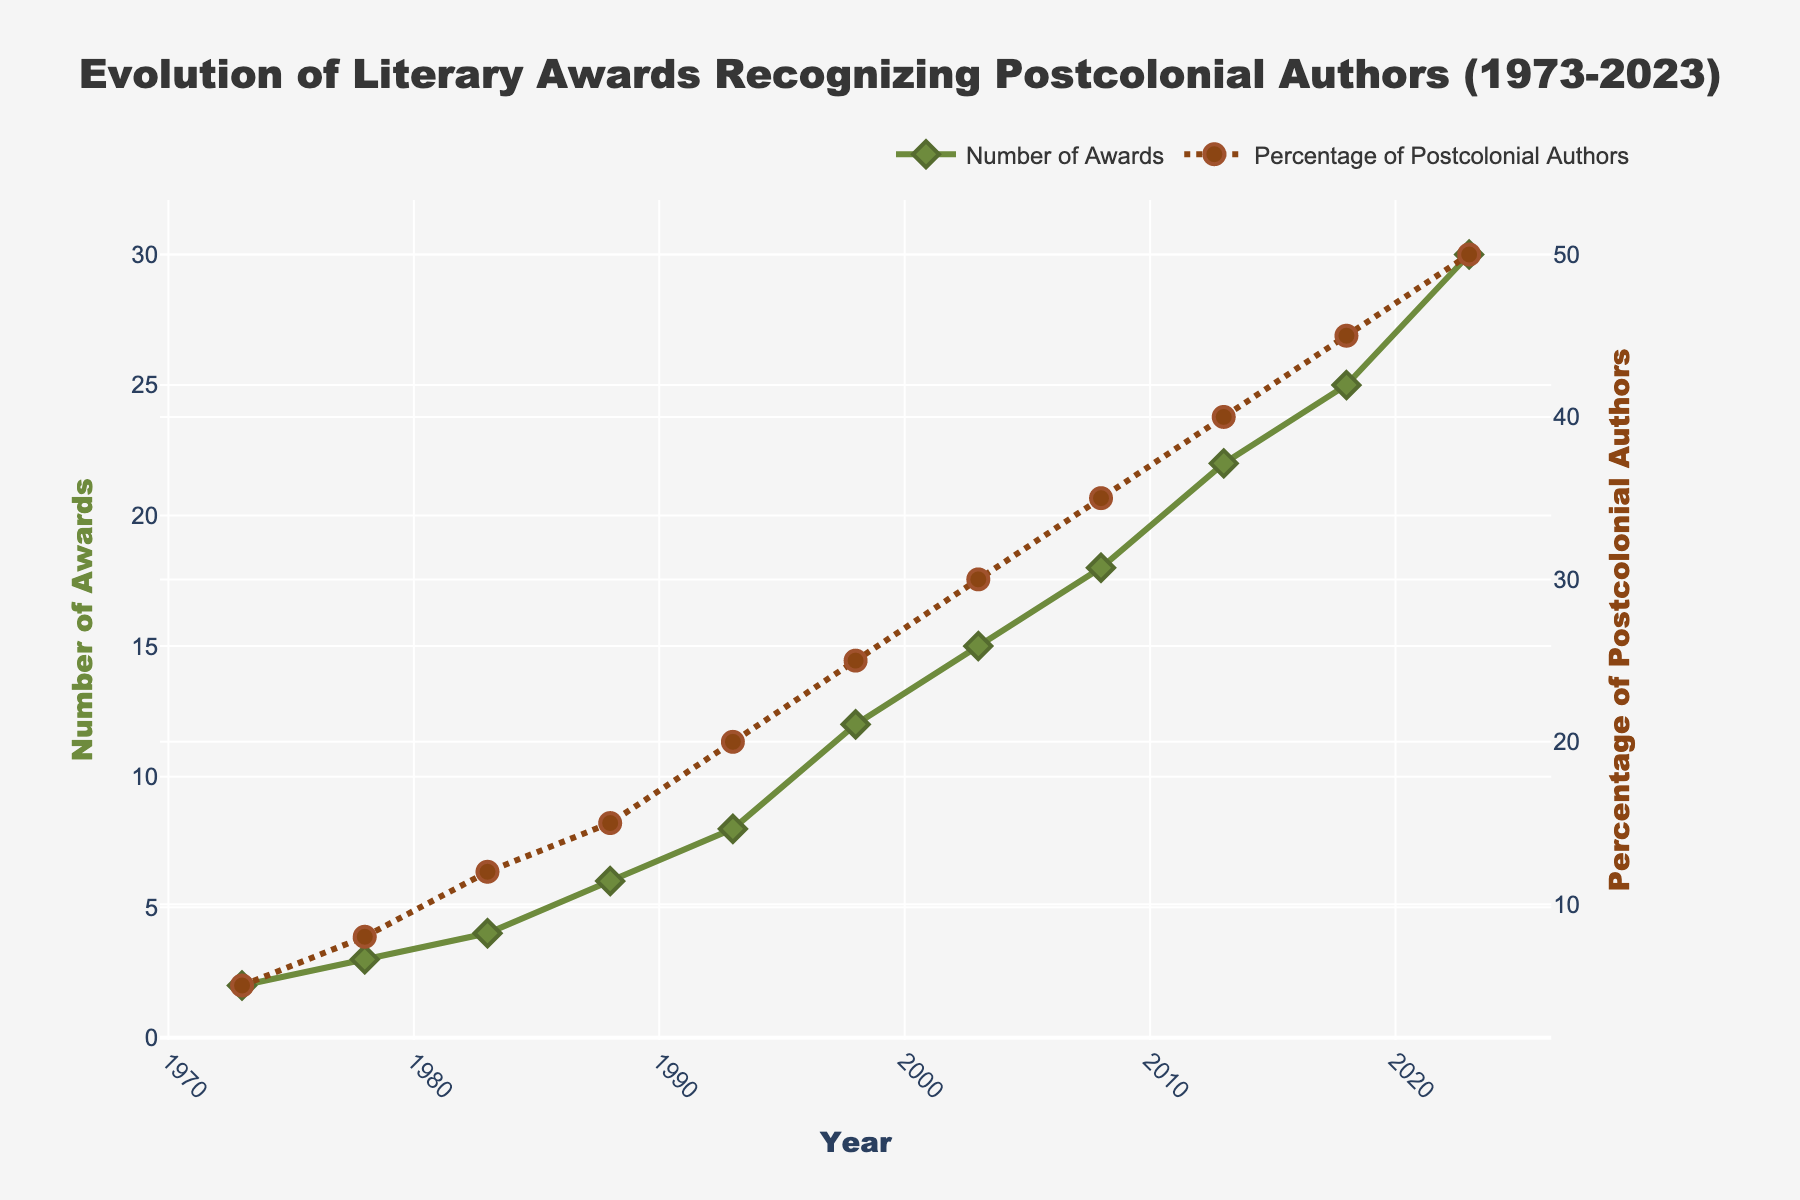What is the total number of awards given in 2023? The figure shows the number of awards given each year. In 2023, the number of awards is plotted as 30, as indicated by the top dot on the "Number of Awards" line.
Answer: 30 How has the percentage of postcolonial authors recognized changed from 1973 to 2023? The percentage of postcolonial authors recognized in 1973 was 5%, and in 2023 it is 50%, showing a significant increase. This change is illustrated by the rising trend on the "Percentage of Postcolonial Authors" dotted line.
Answer: Increased by 45 percentage points Between which consecutive years did the number of awards increase the most? By examining the "Number of Awards" green line, the steepest increase appears between 1998 and 2003, where the number of awards increased from 12 to 15. This shows an increase of 3 awards.
Answer: 1998 to 2003 What is the difference between the percentage of postcolonial authors recognized in 2003 and 2013? The percentage of postcolonial authors recognized in 2003 was 30%, and in 2013 it was 40%. The difference is computed as 40% - 30%.
Answer: 10% Compare the number of awards given in 1988 to the number given in 1998. Which year had more awards and by how many? The figure shows that in 1988 the number of awards was 6, and in 1998 it was 12. By subtracting the values, it is clear that 1998 had 6 more awards than 1988.
Answer: 1998 had 6 more awards Which year had a higher percentage of postcolonial authors recognized: 2008 or 2018? By reviewing the "Percentage of Postcolonial Authors" line, 2008 had a percentage of 35%, and 2018 had 45%. Thus, 2018 had a higher percentage.
Answer: 2018 Calculate the average number of awards over the past 50 years. Summing the number of awards (2 + 3 + 4 + 6 + 8 + 12 + 15 + 18 + 22 + 25 + 30) gives 145. Dividing by the number of data points (11) gives 145/11.
Answer: 13.18 What was the percentage increase in the number of awards from 1983 to 1988? The number of awards in 1983 was 4, and in 1988 it was 6. The percentage increase is calculated as ((6 - 4) / 4) * 100.
Answer: 50% Based on the trends, discuss the reasons why there might be an increase in the number of awards recognizing postcolonial authors. The patterns in the figure show a steady increase in both the number of awards and the percentage of postcolonial authors recognized. Possible reasons could include growing awareness and appreciation for postcolonial literature, more inclusive award criteria, and increased publication opportunities for these authors. However, the detailed reasons would require further sociocultural and historical analysis beyond the figure itself.
Answer: Increased recognition and inclusivity What can you infer about the trend in recognizing postcolonial authors over the past 50 years? The steady rise in both the number of awards and the percentage of postcolonial authors recognized suggests a positive trend towards inclusivity and recognition of diverse voices in literature. The visual evidence shows a significant and consistent upward trend.
Answer: Positive trend towards inclusivity 